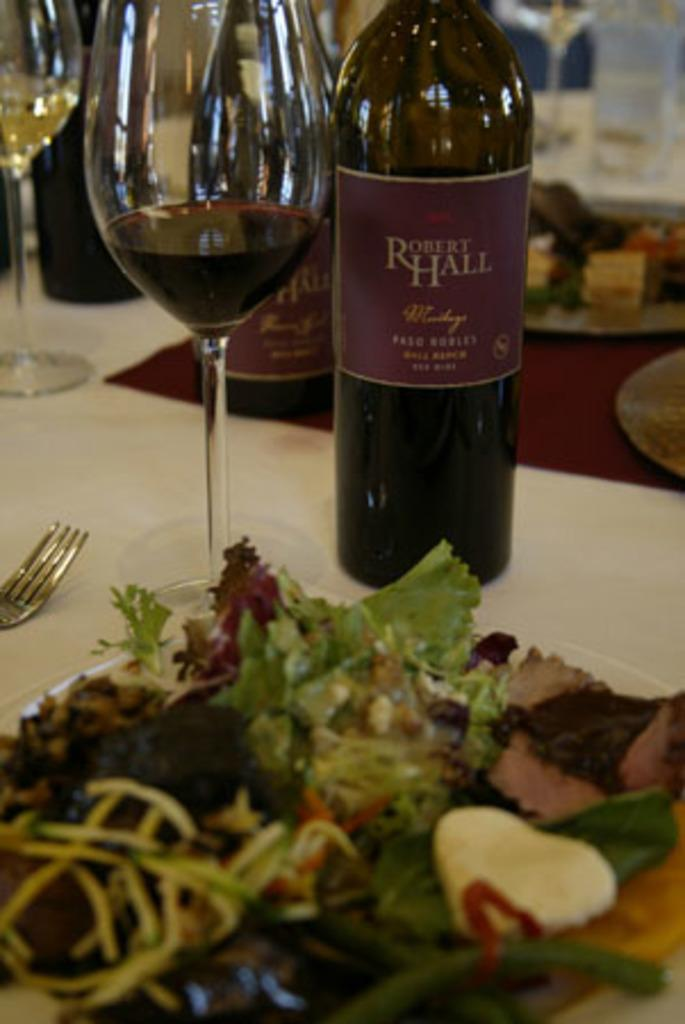What type of container is visible in the image? There is a glass in the image. What other container can be seen in the image? There is a bottle in the image. What is the color of the bottle? The bottle is brown in color. What is on the plate in the image? There is a plate full of eatables in the image. What utensil is present on the table in the image? There is a fork on the table in the image. What type of school can be seen in the background of the image? There is no school present in the image; it only features a glass, a brown bottle, a plate full of eatables, and a fork on the table. 